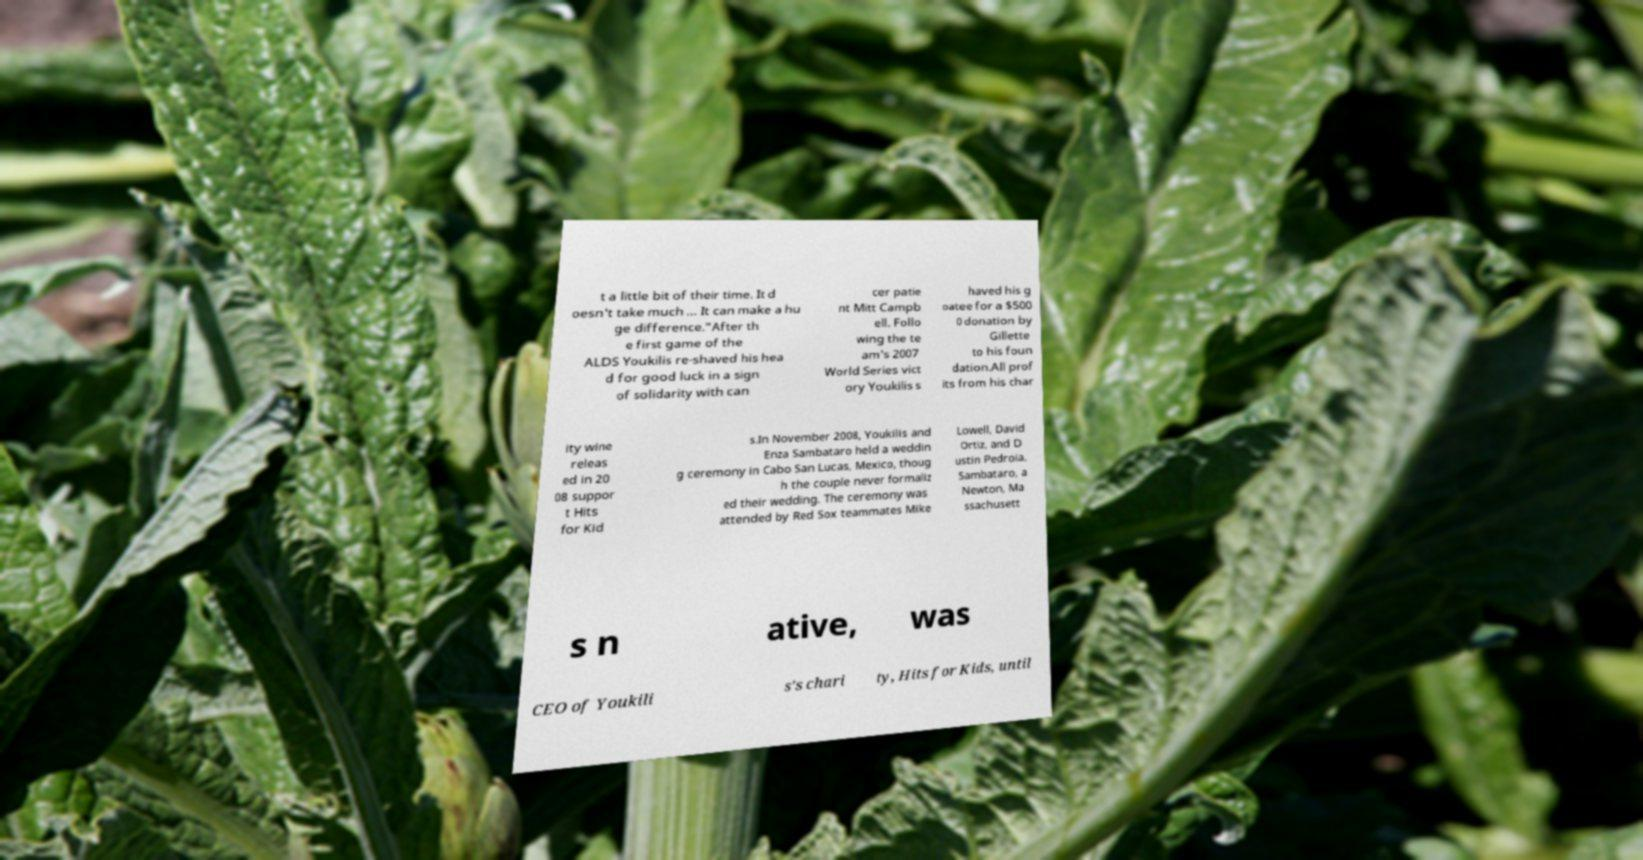Could you extract and type out the text from this image? t a little bit of their time. It d oesn't take much … It can make a hu ge difference."After th e first game of the ALDS Youkilis re-shaved his hea d for good luck in a sign of solidarity with can cer patie nt Mitt Campb ell. Follo wing the te am's 2007 World Series vict ory Youkilis s haved his g oatee for a $500 0 donation by Gillette to his foun dation.All prof its from his char ity wine releas ed in 20 08 suppor t Hits for Kid s.In November 2008, Youkilis and Enza Sambataro held a weddin g ceremony in Cabo San Lucas, Mexico, thoug h the couple never formaliz ed their wedding. The ceremony was attended by Red Sox teammates Mike Lowell, David Ortiz, and D ustin Pedroia. Sambataro, a Newton, Ma ssachusett s n ative, was CEO of Youkili s's chari ty, Hits for Kids, until 